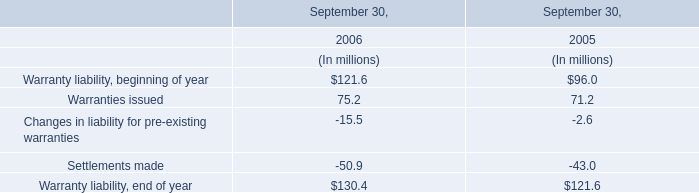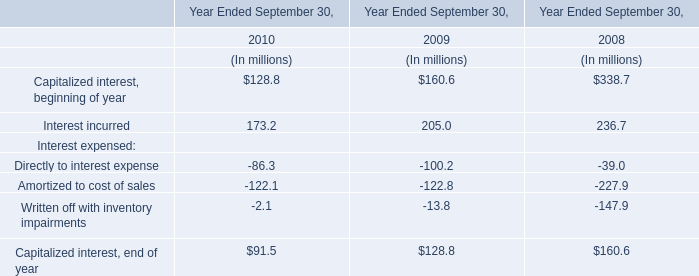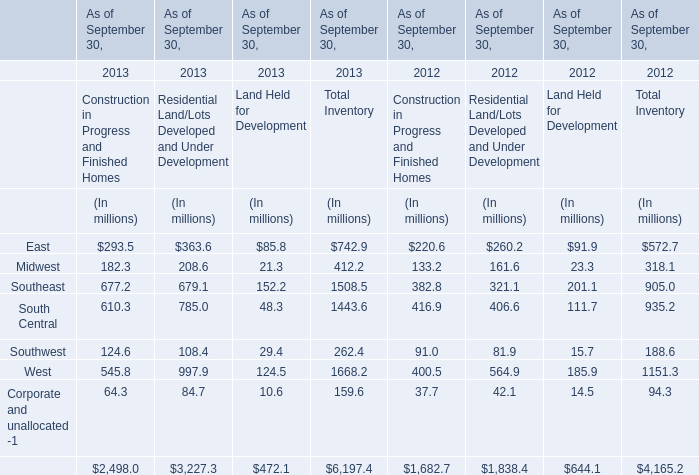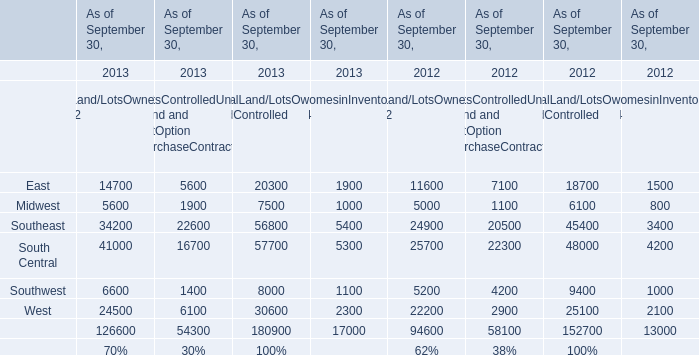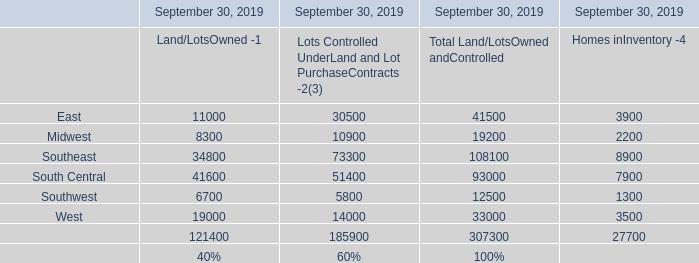What's the total amount of the Southwest in the years where South Central of Residential Land/Lots Developed and Under Development is greater than 500? (in million) 
Computations: ((610.3 + 785) + 48.3)
Answer: 1443.6. 